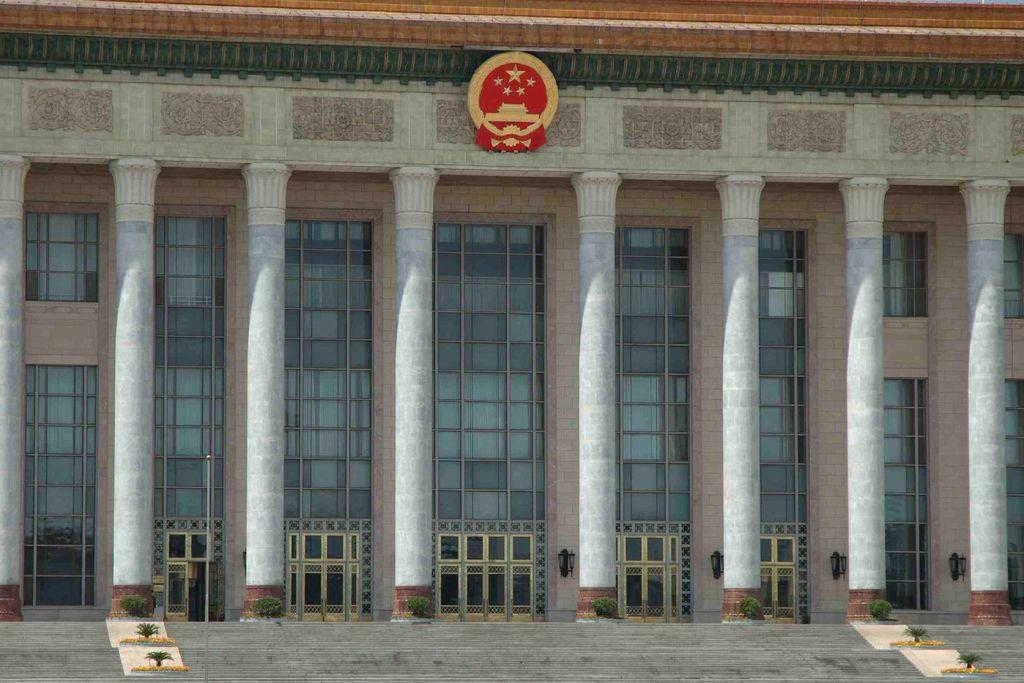What can be seen in the foreground of the image? There are stairs and plants in the foreground of the image. What is located in the middle of the image? There are pillars and a building in the middle of the image. Are there any children playing volleyball on the stairs in the image? There is no mention of children or volleyball in the image; it only features stairs, plants, pillars, and a building. 